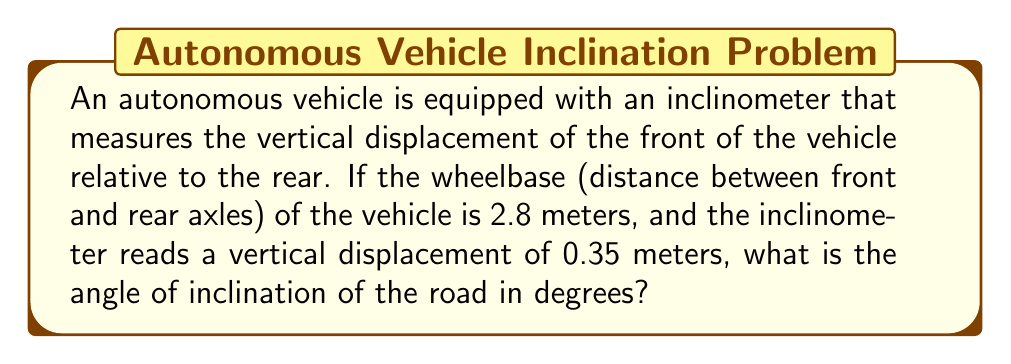Could you help me with this problem? To solve this problem, we can use basic trigonometry. The situation can be modeled as a right triangle, where:

- The hypotenuse is the wheelbase of the vehicle (2.8 meters)
- The opposite side is the vertical displacement (0.35 meters)
- The angle we're looking for is the one between the road surface and the horizontal plane

Let's approach this step-by-step:

1) We can use the sine function to find the angle. In a right triangle, sine of an angle is the ratio of the opposite side to the hypotenuse.

2) Let $\theta$ be the angle of inclination. Then:

   $$\sin(\theta) = \frac{\text{opposite}}{\text{hypotenuse}} = \frac{0.35}{2.8}$$

3) To find $\theta$, we need to take the inverse sine (arcsin) of both sides:

   $$\theta = \arcsin(\frac{0.35}{2.8})$$

4) Using a calculator or computer:

   $$\theta \approx 0.1253 \text{ radians}$$

5) To convert this to degrees, we multiply by $\frac{180}{\pi}$:

   $$\theta \approx 0.1253 \cdot \frac{180}{\pi} \approx 7.18°$$

Thus, the angle of inclination of the road is approximately 7.18 degrees.

[asy]
import geometry;

size(200);
pair A=(0,0), B=(10,0), C=(10,1.25);
draw(A--B--C--A);
draw(rightanglemark(A,B,C,2));
label("2.8 m",B--A,S);
label("0.35 m",B--C,E);
label("$\theta$",A,NW);
[/asy]
Answer: $\theta \approx 7.18°$ 